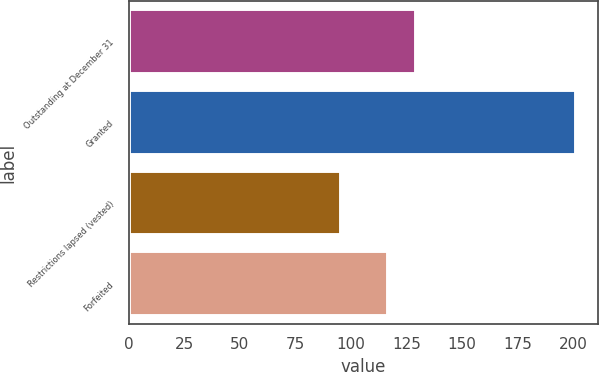<chart> <loc_0><loc_0><loc_500><loc_500><bar_chart><fcel>Outstanding at December 31<fcel>Granted<fcel>Restrictions lapsed (vested)<fcel>Forfeited<nl><fcel>129.05<fcel>201.22<fcel>95.35<fcel>116.53<nl></chart> 